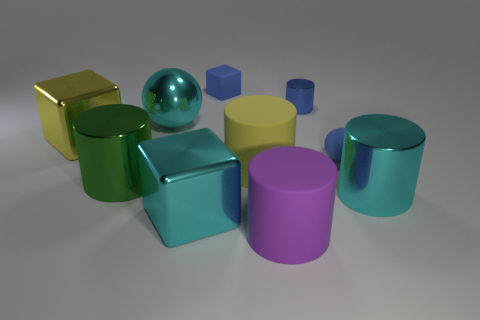Subtract all spheres. How many objects are left? 8 Subtract all big shiny cubes. How many cubes are left? 1 Subtract 0 brown cubes. How many objects are left? 10 Subtract 3 cylinders. How many cylinders are left? 2 Subtract all red cylinders. Subtract all gray spheres. How many cylinders are left? 5 Subtract all red cubes. How many yellow balls are left? 0 Subtract all small blue spheres. Subtract all small metal cylinders. How many objects are left? 8 Add 6 big green metallic objects. How many big green metallic objects are left? 7 Add 3 big blocks. How many big blocks exist? 5 Subtract all yellow cylinders. How many cylinders are left? 4 